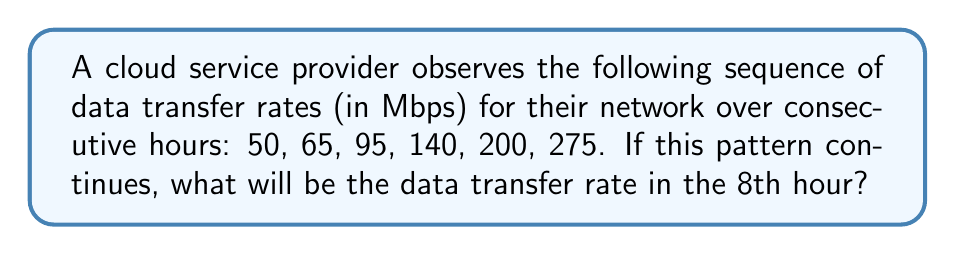Provide a solution to this math problem. Let's analyze the pattern step-by-step:

1) First, calculate the differences between consecutive terms:
   65 - 50 = 15
   95 - 65 = 30
   140 - 95 = 45
   200 - 140 = 60
   275 - 200 = 75

2) We can see that the differences are increasing by 15 each time:
   15, 30, 45, 60, 75

3) This suggests that the sequence follows a quadratic pattern.

4) Let's denote the nth term of the sequence as $a_n$. We can represent it as:
   $a_n = an^2 + bn + c$, where $a$, $b$, and $c$ are constants we need to find.

5) Using the first three terms of the sequence, we can set up a system of equations:
   $a_1 = a(1)^2 + b(1) + c = 50$
   $a_2 = a(2)^2 + b(2) + c = 65$
   $a_3 = a(3)^2 + b(3) + c = 95$

6) Subtracting the equations:
   $a_2 - a_1 = 3a + b = 15$
   $a_3 - a_2 = 5a + b = 30$

7) Subtracting these new equations:
   $2a = 15$
   $a = 7.5$

8) Substituting back:
   $3(7.5) + b = 15$
   $b = 15 - 22.5 = -7.5$

9) Using $a_1$ equation:
   $7.5 + (-7.5) + c = 50$
   $c = 50$

10) Therefore, the general term is:
    $a_n = 7.5n^2 - 7.5n + 50$

11) For the 8th hour, $n = 8$:
    $a_8 = 7.5(8)^2 - 7.5(8) + 50$
    $= 7.5(64) - 60 + 50$
    $= 480 - 60 + 50$
    $= 470$

Thus, the data transfer rate in the 8th hour will be 470 Mbps.
Answer: 470 Mbps 